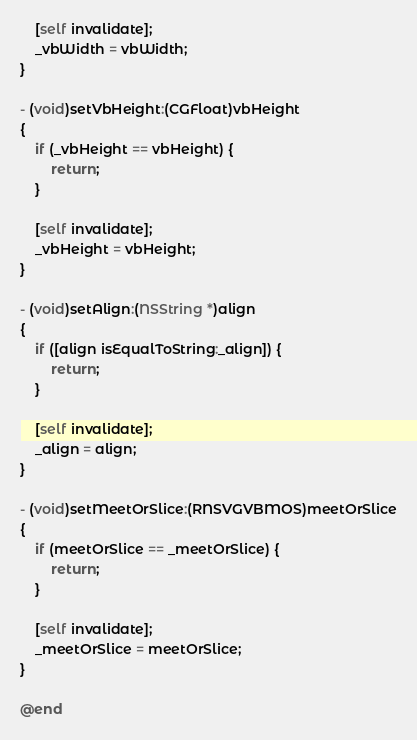Convert code to text. <code><loc_0><loc_0><loc_500><loc_500><_ObjectiveC_>
    [self invalidate];
    _vbWidth = vbWidth;
}

- (void)setVbHeight:(CGFloat)vbHeight
{
    if (_vbHeight == vbHeight) {
        return;
    }

    [self invalidate];
    _vbHeight = vbHeight;
}

- (void)setAlign:(NSString *)align
{
    if ([align isEqualToString:_align]) {
        return;
    }

    [self invalidate];
    _align = align;
}

- (void)setMeetOrSlice:(RNSVGVBMOS)meetOrSlice
{
    if (meetOrSlice == _meetOrSlice) {
        return;
    }

    [self invalidate];
    _meetOrSlice = meetOrSlice;
}

@end

</code> 